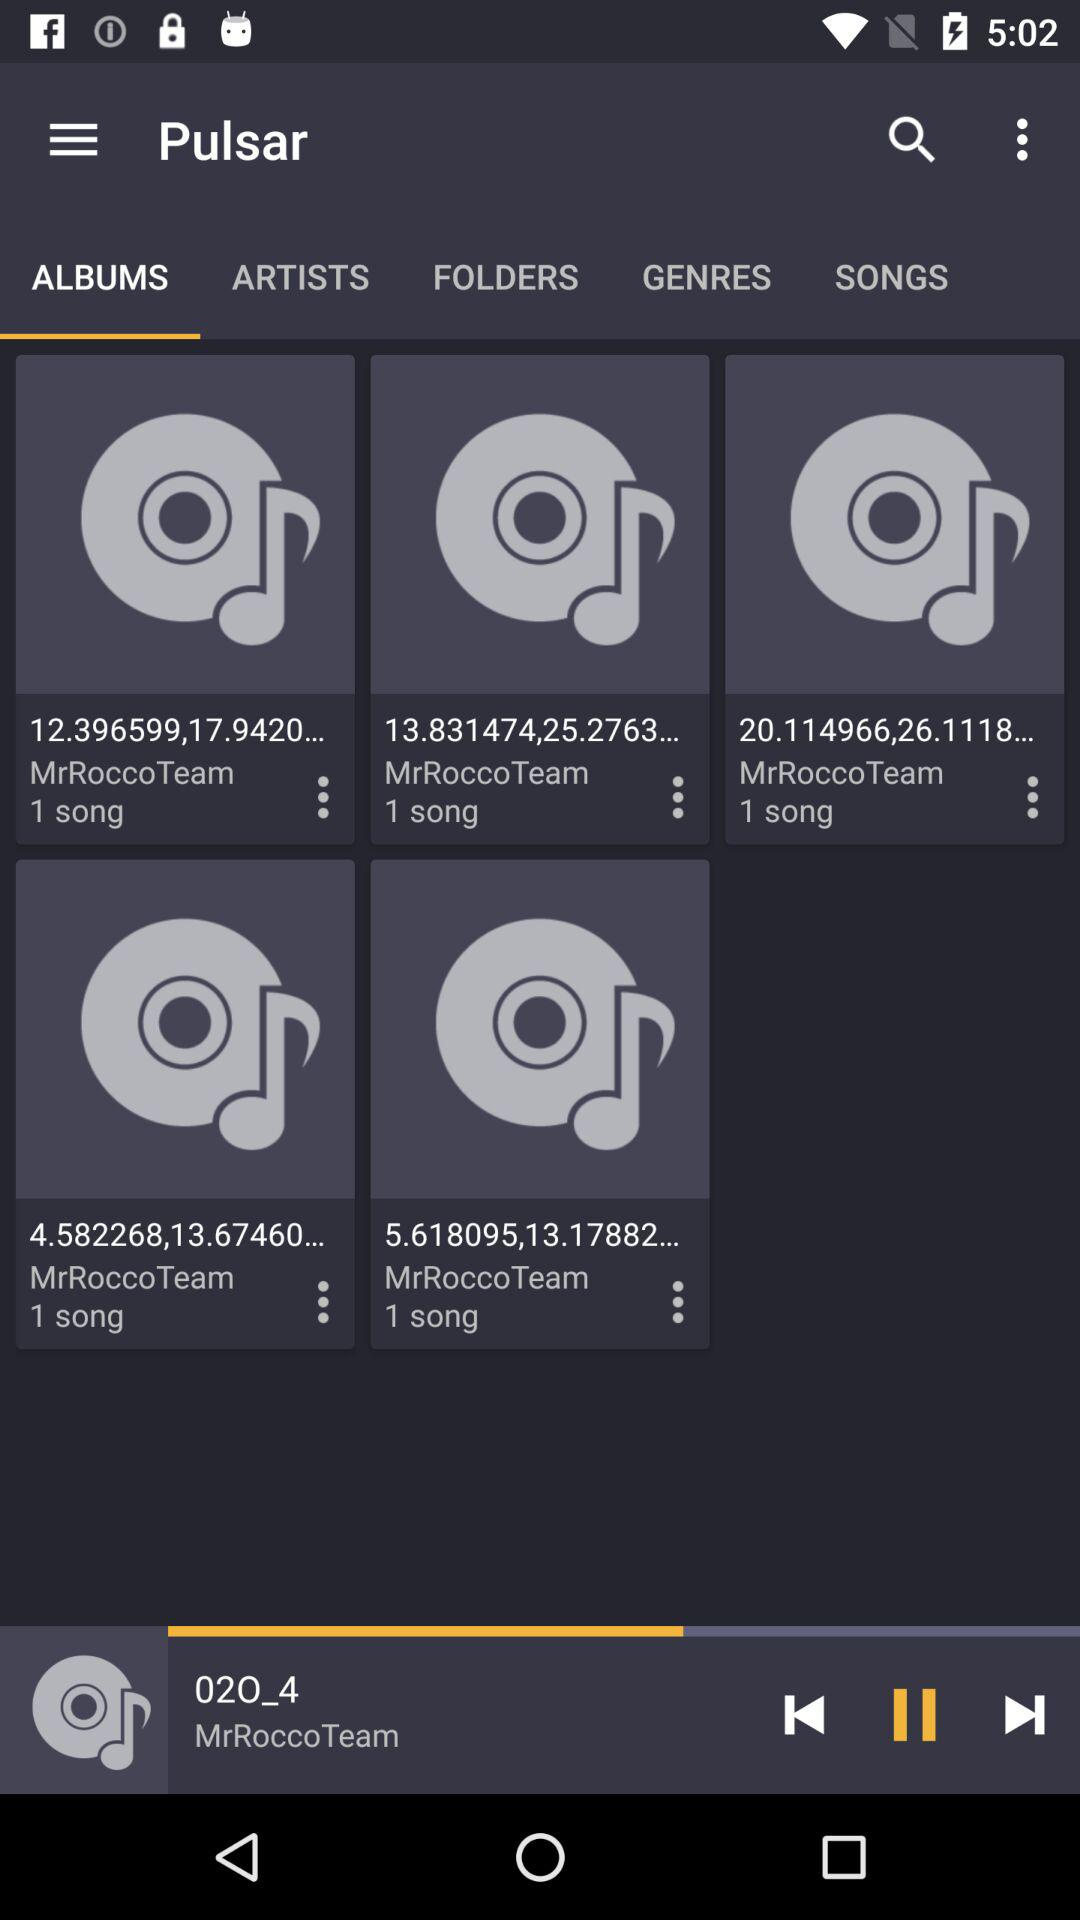What is the name of the application? The name of the application is "Pulsar". 